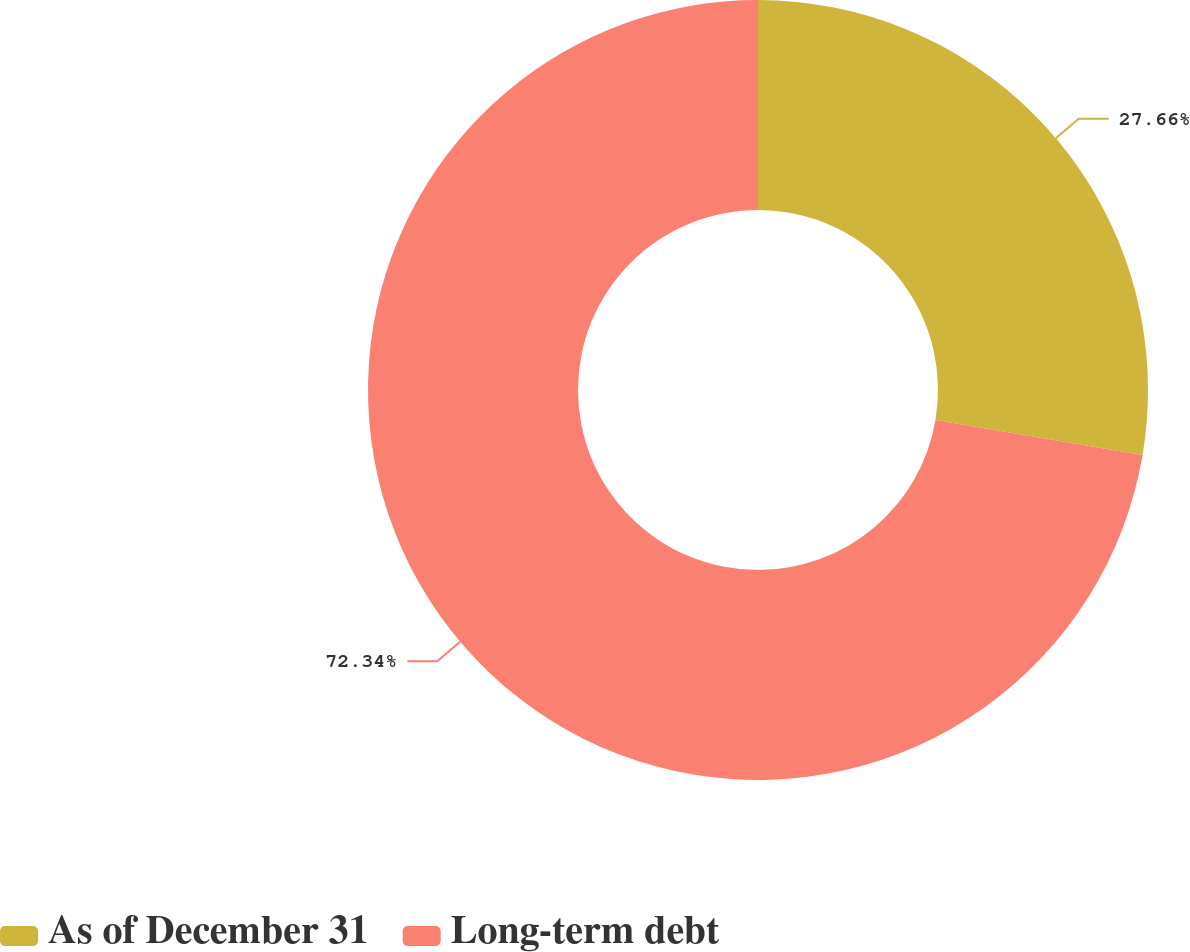Convert chart to OTSL. <chart><loc_0><loc_0><loc_500><loc_500><pie_chart><fcel>As of December 31<fcel>Long-term debt<nl><fcel>27.66%<fcel>72.34%<nl></chart> 